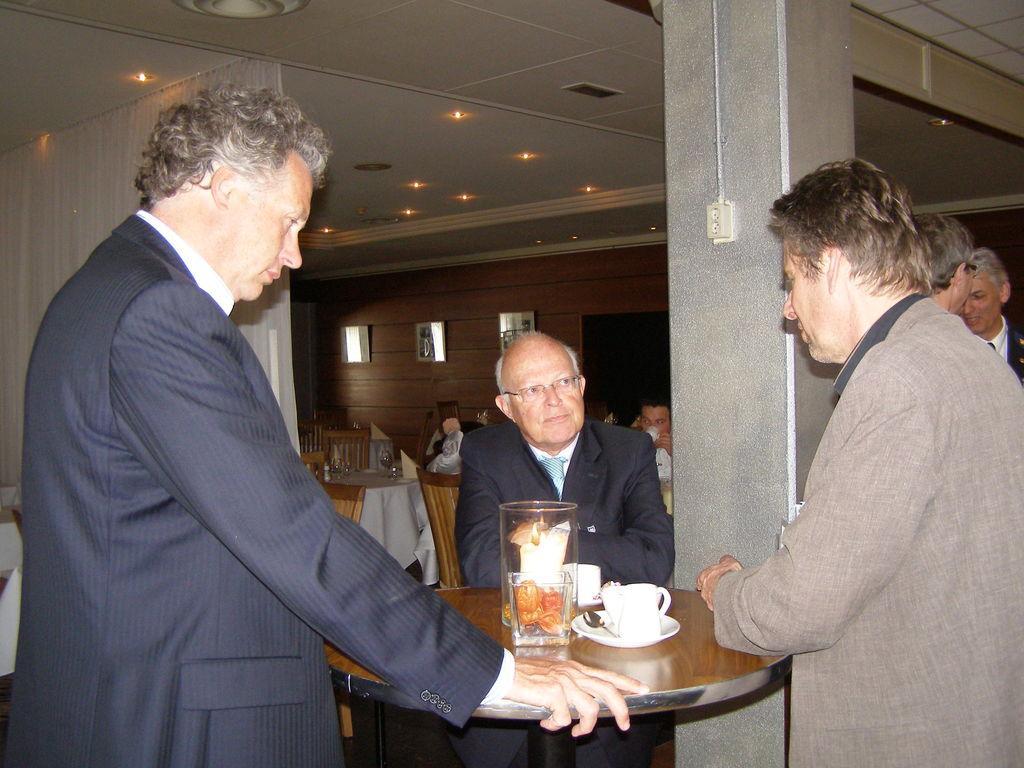Describe this image in one or two sentences. Three men are standing at a table. Three of them are wearing shoes. There some tea cups and a candle on the table. There are some people at tables in the background. The hall is well illuminated with lights on to the roof. 